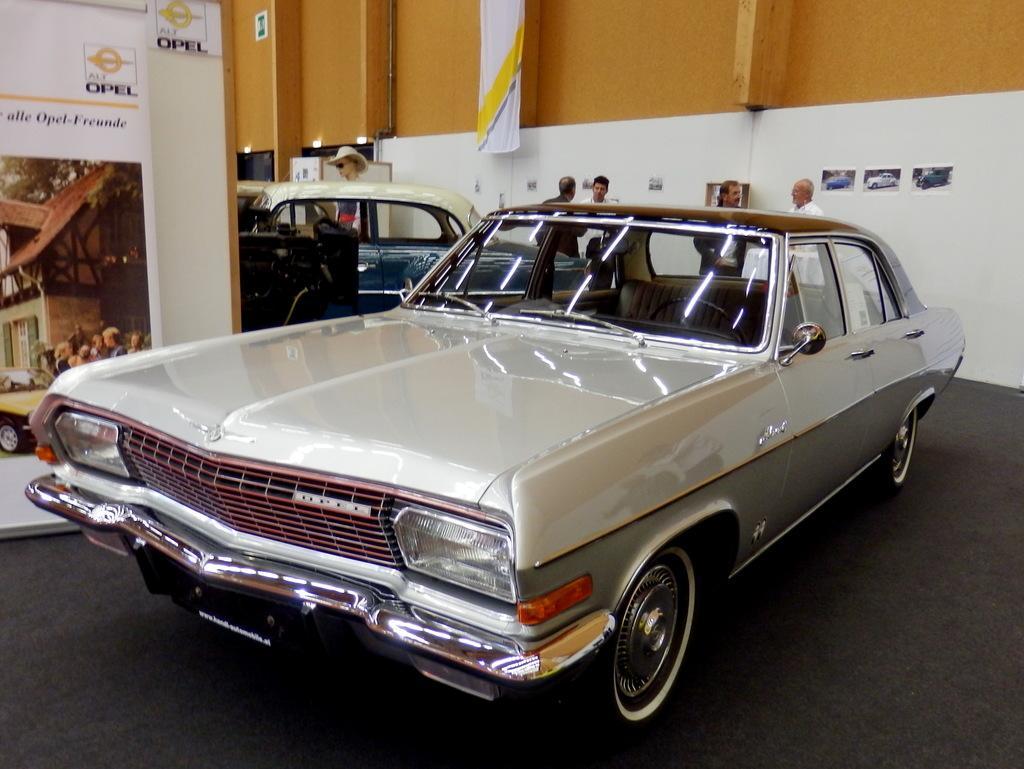Describe this image in one or two sentences. In this image we can see vehicles. Also there are many people. In the back there is a wall. On the wall some images are pasted. Also there is a banner. And we can see statue of a person's head with goggles and hat. In the back there are trees. 